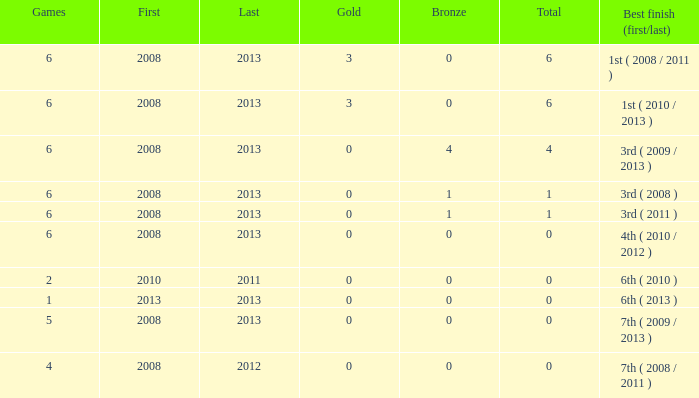What is the smallest number of medals related to less than 6 games and greater than 0 golds? None. 